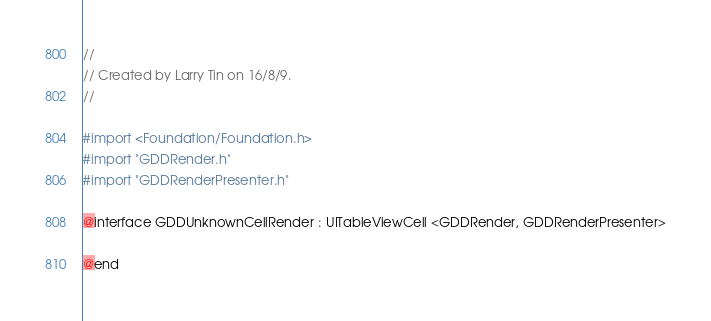<code> <loc_0><loc_0><loc_500><loc_500><_C_>//
// Created by Larry Tin on 16/8/9.
//

#import <Foundation/Foundation.h>
#import "GDDRender.h"
#import "GDDRenderPresenter.h"

@interface GDDUnknownCellRender : UITableViewCell <GDDRender, GDDRenderPresenter>

@end</code> 